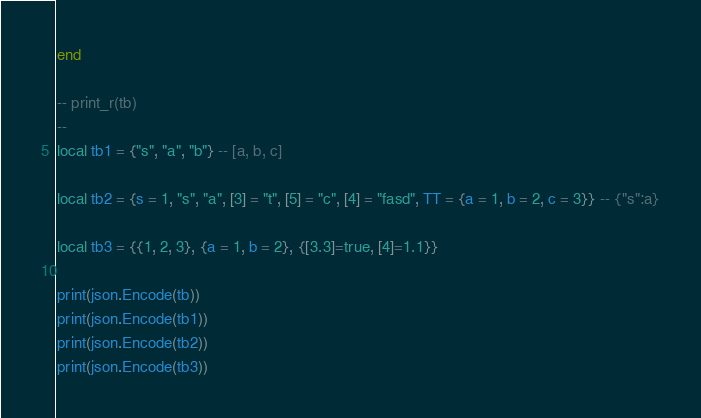<code> <loc_0><loc_0><loc_500><loc_500><_Lua_>end

-- print_r(tb)
--
local tb1 = {"s", "a", "b"} -- [a, b, c]

local tb2 = {s = 1, "s", "a", [3] = "t", [5] = "c", [4] = "fasd", TT = {a = 1, b = 2, c = 3}} -- {"s":a}

local tb3 = {{1, 2, 3}, {a = 1, b = 2}, {[3.3]=true, [4]=1.1}}

print(json.Encode(tb))
print(json.Encode(tb1))
print(json.Encode(tb2))
print(json.Encode(tb3))
</code> 